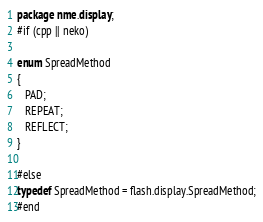Convert code to text. <code><loc_0><loc_0><loc_500><loc_500><_Haxe_>package nme.display;
#if (cpp || neko)

enum SpreadMethod 
{
   PAD;
   REPEAT;
   REFLECT;
}

#else
typedef SpreadMethod = flash.display.SpreadMethod;
#end</code> 